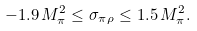<formula> <loc_0><loc_0><loc_500><loc_500>- 1 . 9 \, M _ { \pi } ^ { 2 } \leq \sigma _ { \pi \rho } \leq 1 . 5 \, M _ { \pi } ^ { 2 } .</formula> 